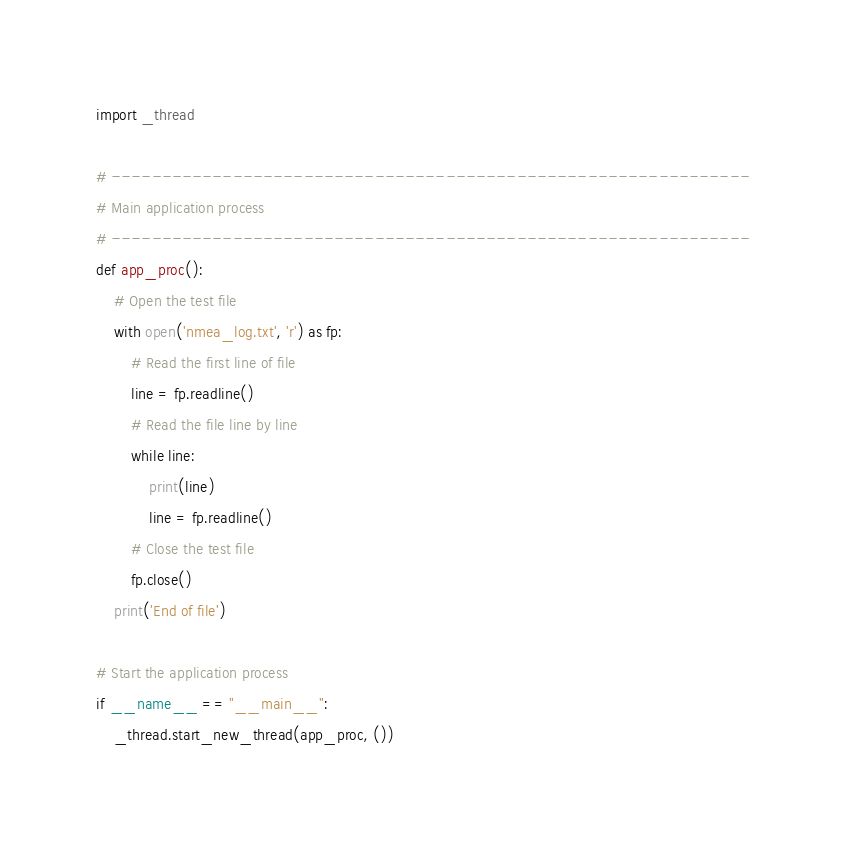<code> <loc_0><loc_0><loc_500><loc_500><_Python_>import _thread

# ---------------------------------------------------------------
# Main application process
# ---------------------------------------------------------------
def app_proc():
    # Open the test file
    with open('nmea_log.txt', 'r') as fp:
        # Read the first line of file
        line = fp.readline()
        # Read the file line by line
        while line:
            print(line)
            line = fp.readline()
        # Close the test file
        fp.close()
    print('End of file')

# Start the application process
if __name__ == "__main__":
    _thread.start_new_thread(app_proc, ())
</code> 